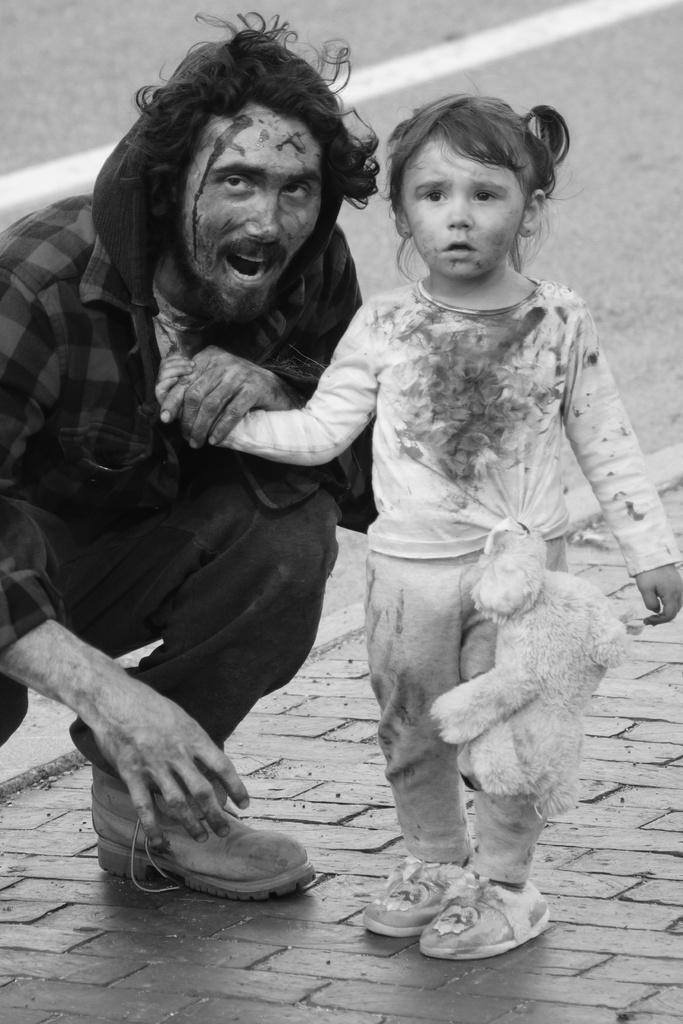Who is present in the image? There is a girl, a soft toy, and a man in the image. What is the man doing with the girl? The man is holding the girl's hand. Where does the scene take place? The scene takes place on a sidewalk. What can be seen in the background of the image? There is a road visible in the background of the image. What is the name of the soft toy in the image? The provided facts do not mention the name of the soft toy, so we cannot determine its name from the image. 